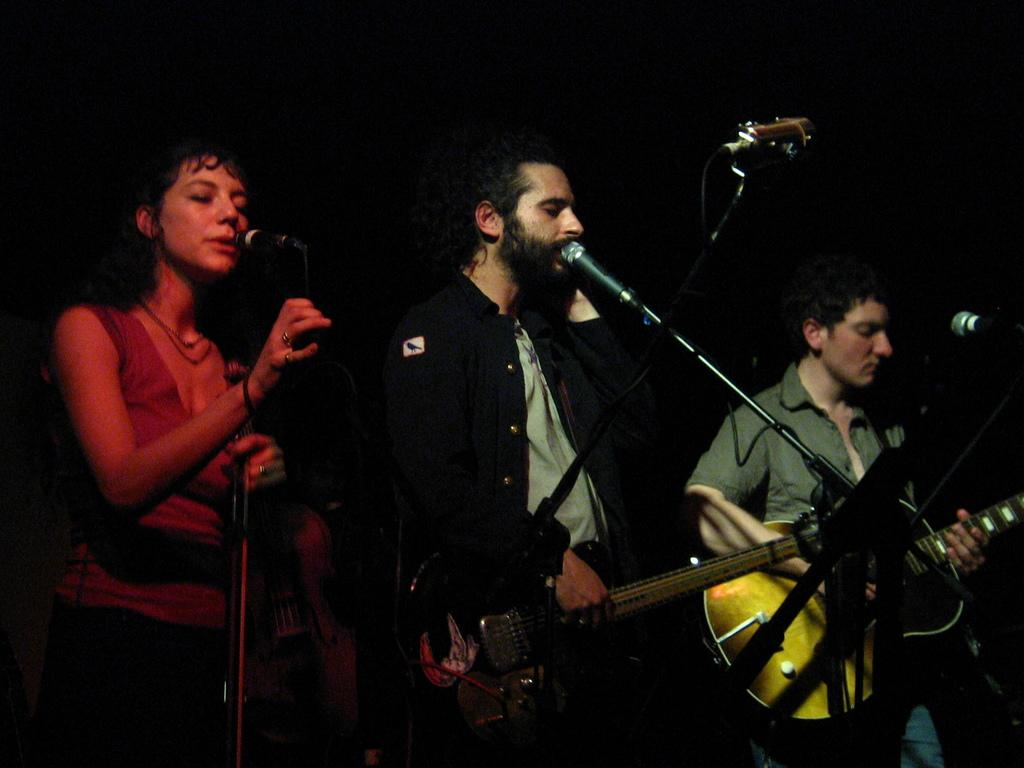How many people are in the image? There are three people in the image. What are the people holding in the image? The people are holding guitars. What are the people doing in the image? The people are singing. What object is present in the image that might be used for amplifying sound? There is a microphone in the image. Can you tell me how many children are participating in the fight in the image? There is no fight or children present in the image; it features three people holding guitars and singing. What position is the person on the left side of the image playing their guitar in? There is no specific position mentioned for the person on the left side of the image; they are simply holding a guitar. 